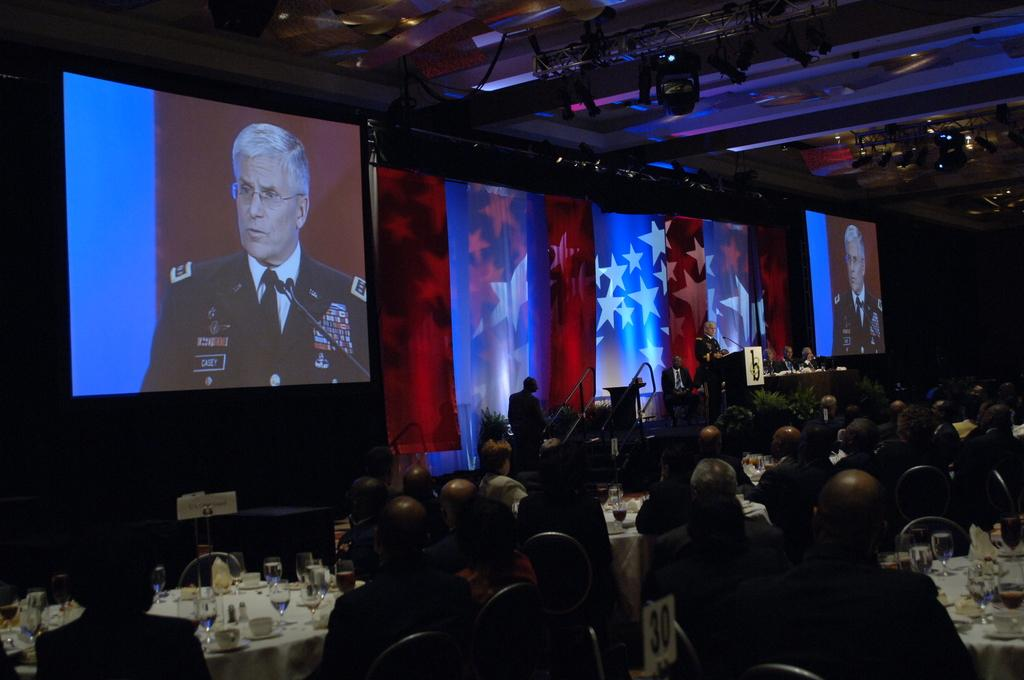What can be seen on the screens in the image? The content on the screens is not specified in the facts provided. How are the people arranged in the image? There is a group of people sitting on chairs in the image. What device is used to display content on the screens? There is a projector in the image. What type of furniture is present in the image? There are tables in the image. What items can be found on the tables? There are glasses and tissue on the tables. Can you tell me how many quarters are visible in the image? There is no mention of quarters in the image; the facts provided only mention screens, a group of people, a projector, tables, glasses, and tissue. 